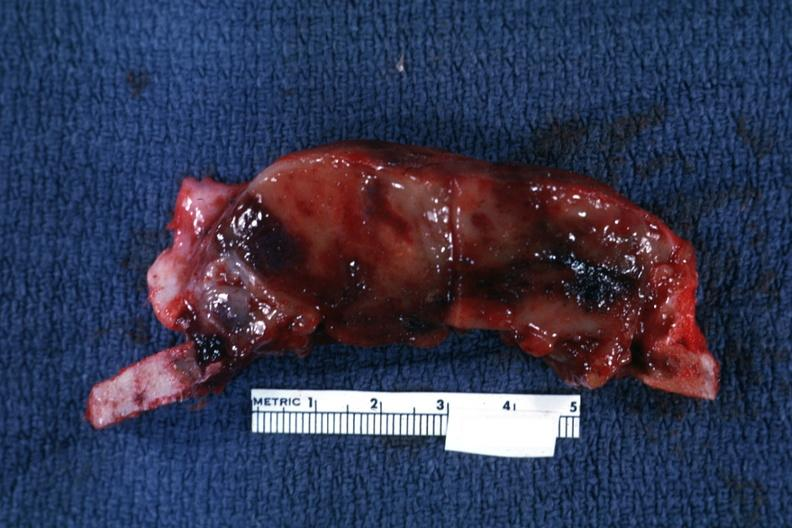s joints present?
Answer the question using a single word or phrase. Yes 